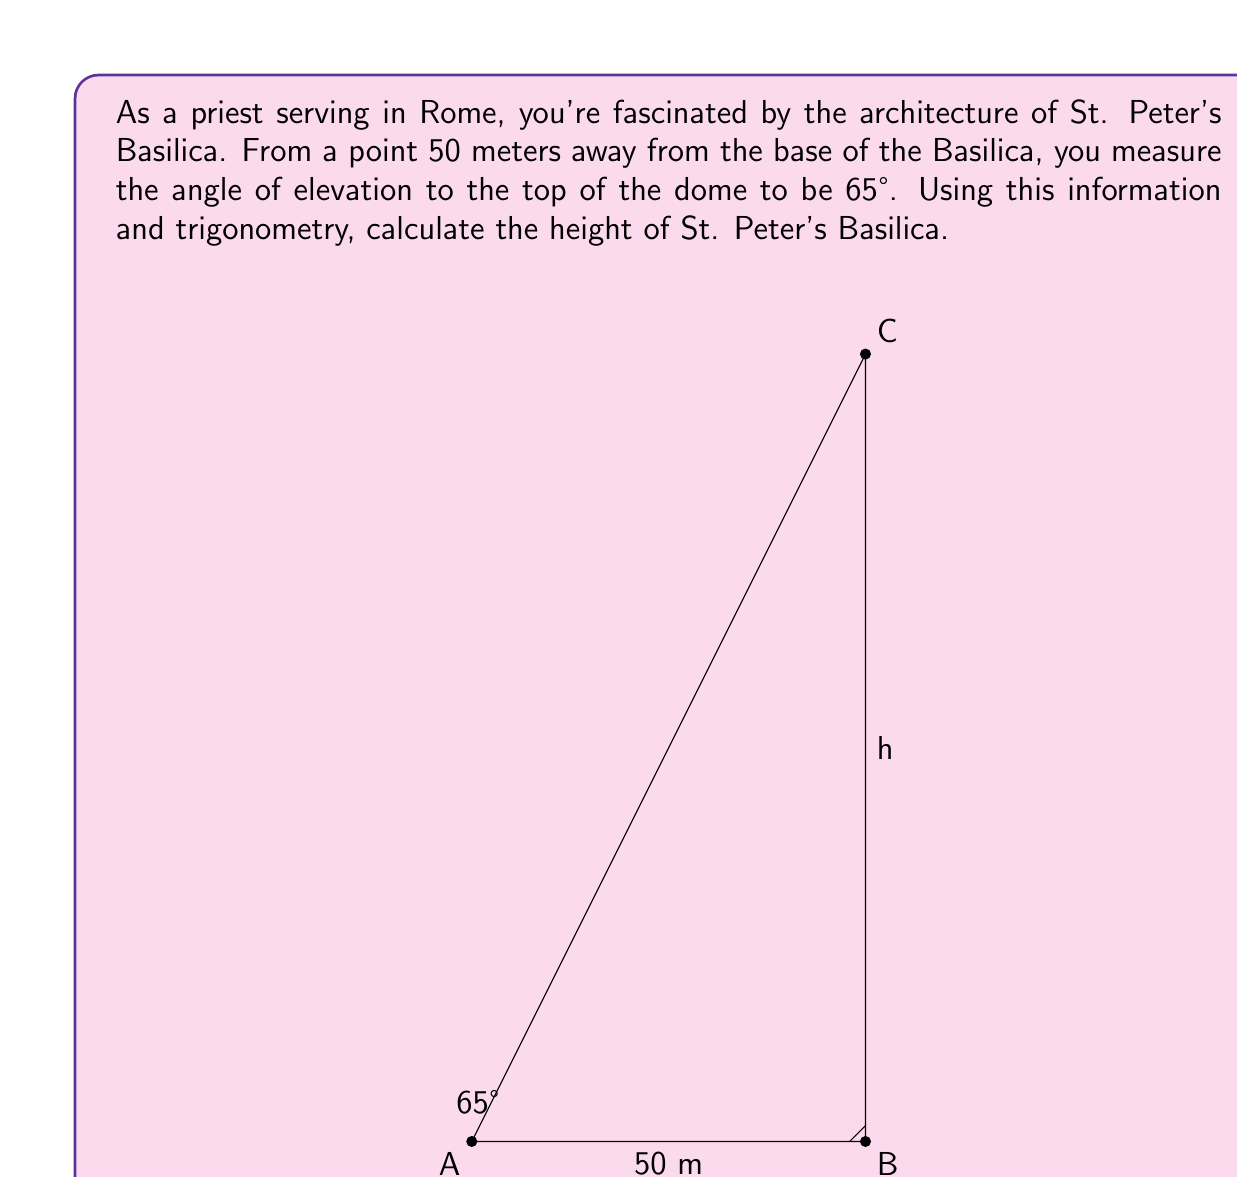What is the answer to this math problem? To solve this problem, we'll use the tangent function from trigonometry. The tangent of an angle in a right triangle is the ratio of the opposite side to the adjacent side.

Let's break it down step-by-step:

1) In this scenario, we have a right triangle where:
   - The adjacent side is the distance from the observer to the base of the Basilica (50 meters)
   - The opposite side is the height of the Basilica (which we'll call h)
   - The angle of elevation is 65°

2) The tangent of 65° is equal to the height divided by the distance:

   $$\tan(65°) = \frac{h}{50}$$

3) To find h, we multiply both sides by 50:

   $$h = 50 \cdot \tan(65°)$$

4) Now, let's calculate:
   
   $$\begin{align}
   h &= 50 \cdot \tan(65°) \\
   &= 50 \cdot 2.1445 \\
   &= 107.2254... \text{ meters}
   \end{align}$$

5) Rounding to the nearest meter, we get 107 meters.

This method provides an approximate height of St. Peter's Basilica, assuming the ground is perfectly level and neglecting the curvature of the Earth.
Answer: The approximate height of St. Peter's Basilica is 107 meters. 